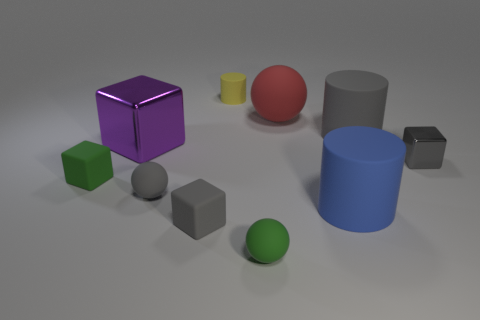What is the color distribution among the objects? There seems to be a variety of colors among the objects: purple, red, green, blue, yellow, and gray. Each color is represented by a single object, except for the green which is present in two objects – a cube and a sphere.  Do the objects give any indication of the material they are made of, based on their appearance? Based on their appearance, the objects seem to have different finishes suggesting different materials. The shiny finish on the gray cube indicates it could be metallic, while the dull, matte finish of the other objects suggests they could be made of plastic or some other non-metallic material. 